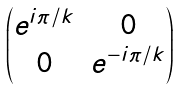<formula> <loc_0><loc_0><loc_500><loc_500>\begin{pmatrix} e ^ { i \pi / k } & 0 \\ 0 & e ^ { - i \pi / k } \end{pmatrix}</formula> 